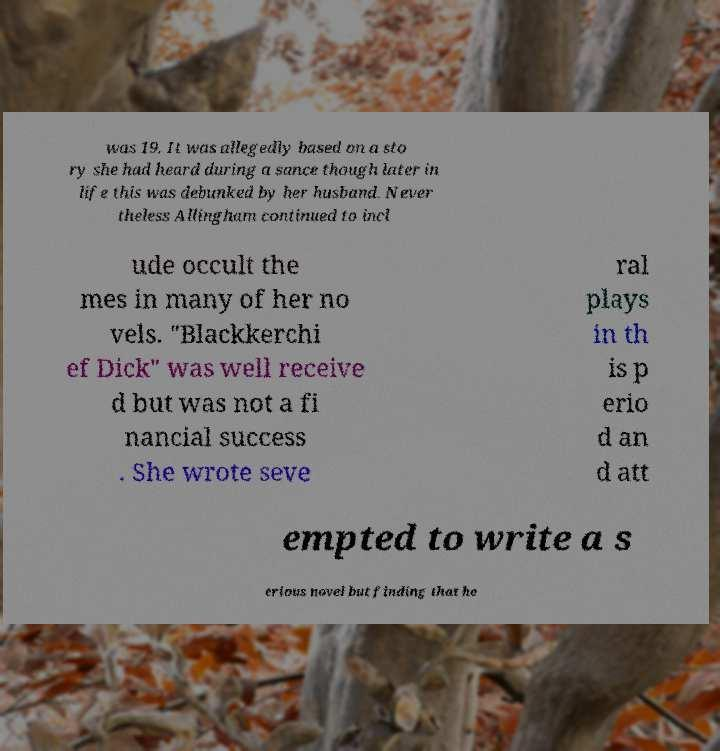For documentation purposes, I need the text within this image transcribed. Could you provide that? was 19. It was allegedly based on a sto ry she had heard during a sance though later in life this was debunked by her husband. Never theless Allingham continued to incl ude occult the mes in many of her no vels. "Blackkerchi ef Dick" was well receive d but was not a fi nancial success . She wrote seve ral plays in th is p erio d an d att empted to write a s erious novel but finding that he 